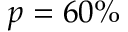Convert formula to latex. <formula><loc_0><loc_0><loc_500><loc_500>p = 6 0 \%</formula> 